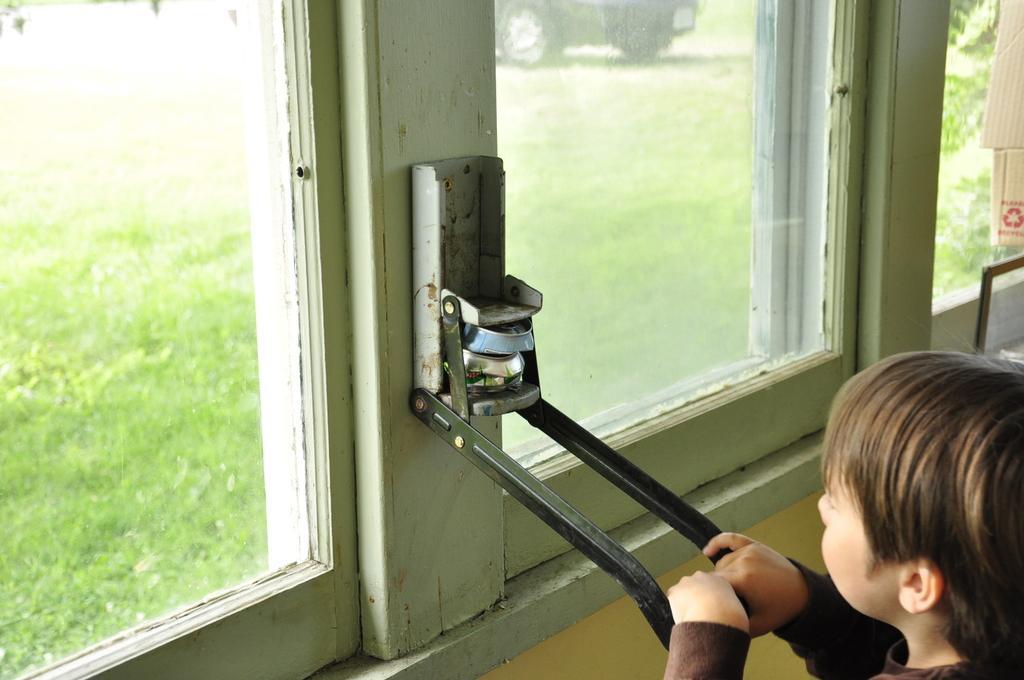In one or two sentences, can you explain what this image depicts? In the center of the image we can see an object. In the bottom right corner we can see a boy is holding an object. In the background of the image we can see the windows, wall and boards. Through the windows we can see the grass and the vehicle. 